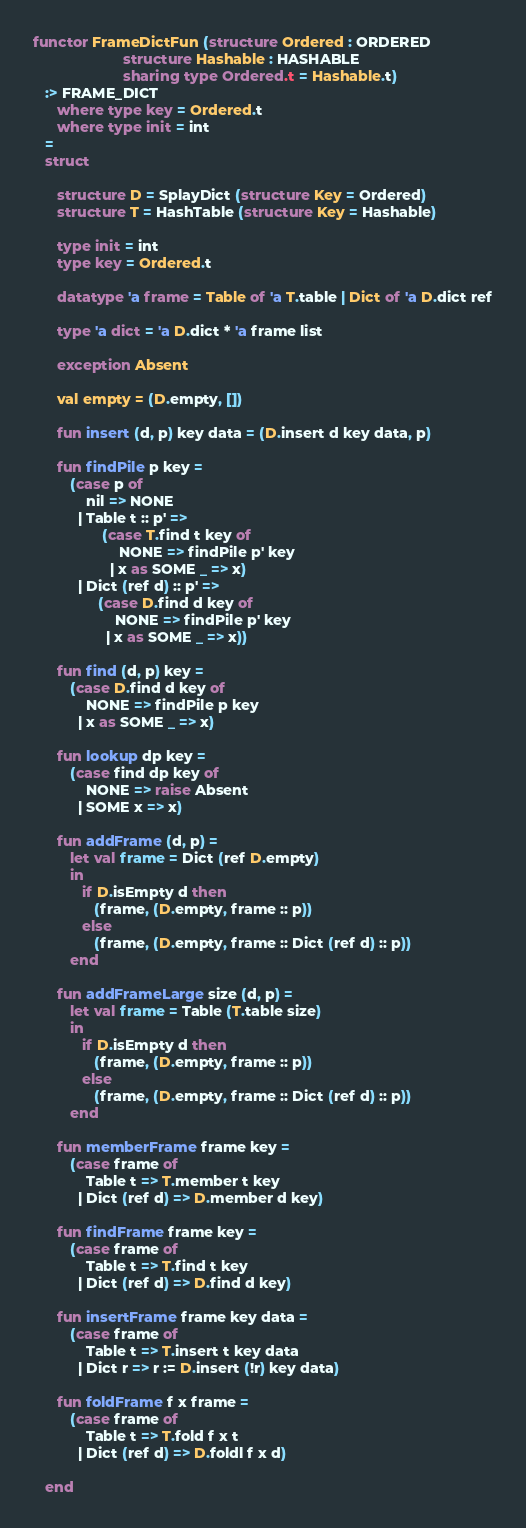<code> <loc_0><loc_0><loc_500><loc_500><_SML_>
functor FrameDictFun (structure Ordered : ORDERED
                      structure Hashable : HASHABLE
                      sharing type Ordered.t = Hashable.t)
   :> FRAME_DICT
      where type key = Ordered.t
      where type init = int
   =
   struct

      structure D = SplayDict (structure Key = Ordered)
      structure T = HashTable (structure Key = Hashable)
      
      type init = int
      type key = Ordered.t

      datatype 'a frame = Table of 'a T.table | Dict of 'a D.dict ref

      type 'a dict = 'a D.dict * 'a frame list

      exception Absent

      val empty = (D.empty, [])

      fun insert (d, p) key data = (D.insert d key data, p)

      fun findPile p key =
         (case p of
             nil => NONE
           | Table t :: p' =>
                 (case T.find t key of
                     NONE => findPile p' key
                   | x as SOME _ => x)
           | Dict (ref d) :: p' =>
                (case D.find d key of
                    NONE => findPile p' key
                  | x as SOME _ => x))

      fun find (d, p) key =
         (case D.find d key of
             NONE => findPile p key
           | x as SOME _ => x)

      fun lookup dp key =
         (case find dp key of
             NONE => raise Absent
           | SOME x => x)

      fun addFrame (d, p) =
         let val frame = Dict (ref D.empty)
         in
            if D.isEmpty d then
               (frame, (D.empty, frame :: p))
            else
               (frame, (D.empty, frame :: Dict (ref d) :: p))
         end

      fun addFrameLarge size (d, p) =
         let val frame = Table (T.table size)
         in
            if D.isEmpty d then
               (frame, (D.empty, frame :: p))
            else
               (frame, (D.empty, frame :: Dict (ref d) :: p))
         end

      fun memberFrame frame key =
         (case frame of
             Table t => T.member t key
           | Dict (ref d) => D.member d key)

      fun findFrame frame key =
         (case frame of
             Table t => T.find t key
           | Dict (ref d) => D.find d key)

      fun insertFrame frame key data =
         (case frame of
             Table t => T.insert t key data
           | Dict r => r := D.insert (!r) key data)

      fun foldFrame f x frame =
         (case frame of
             Table t => T.fold f x t
           | Dict (ref d) => D.foldl f x d)

   end
</code> 